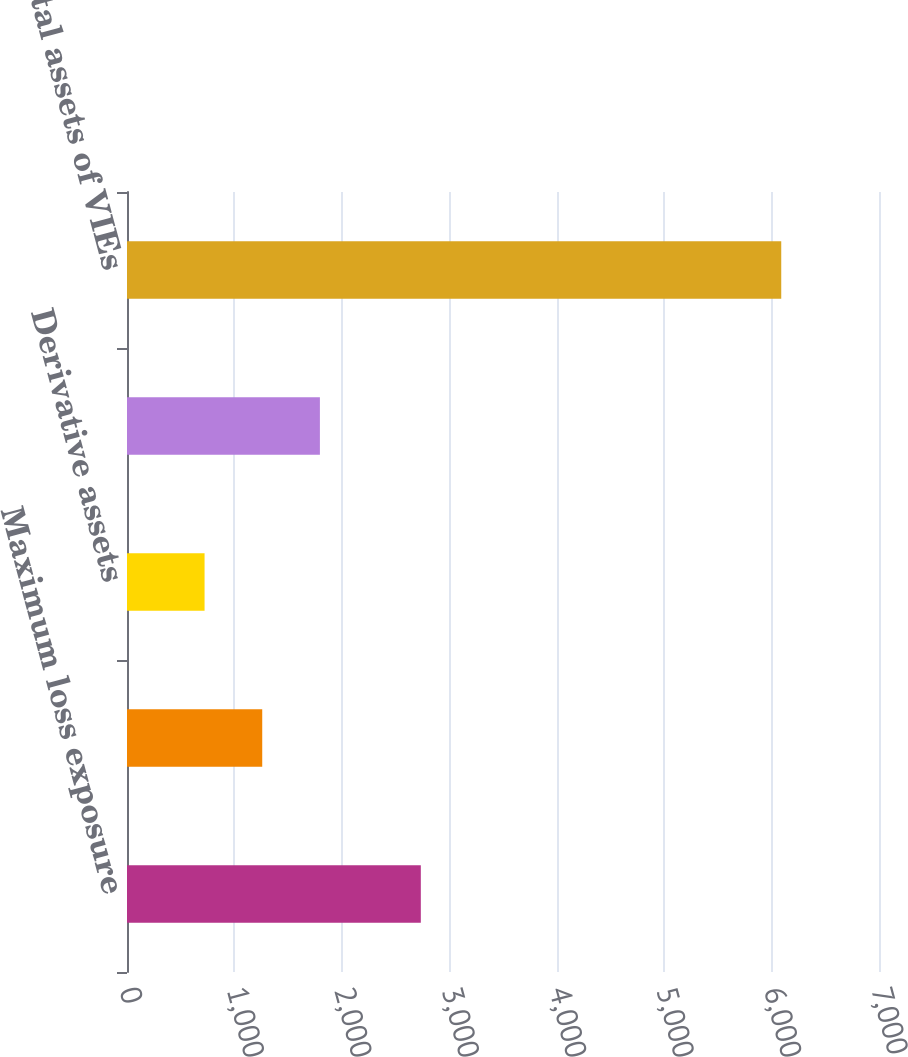Convert chart. <chart><loc_0><loc_0><loc_500><loc_500><bar_chart><fcel>Maximum loss exposure<fcel>Trading account assets<fcel>Derivative assets<fcel>Total<fcel>Total assets of VIEs<nl><fcel>2735<fcel>1258.8<fcel>722<fcel>1795.6<fcel>6090<nl></chart> 